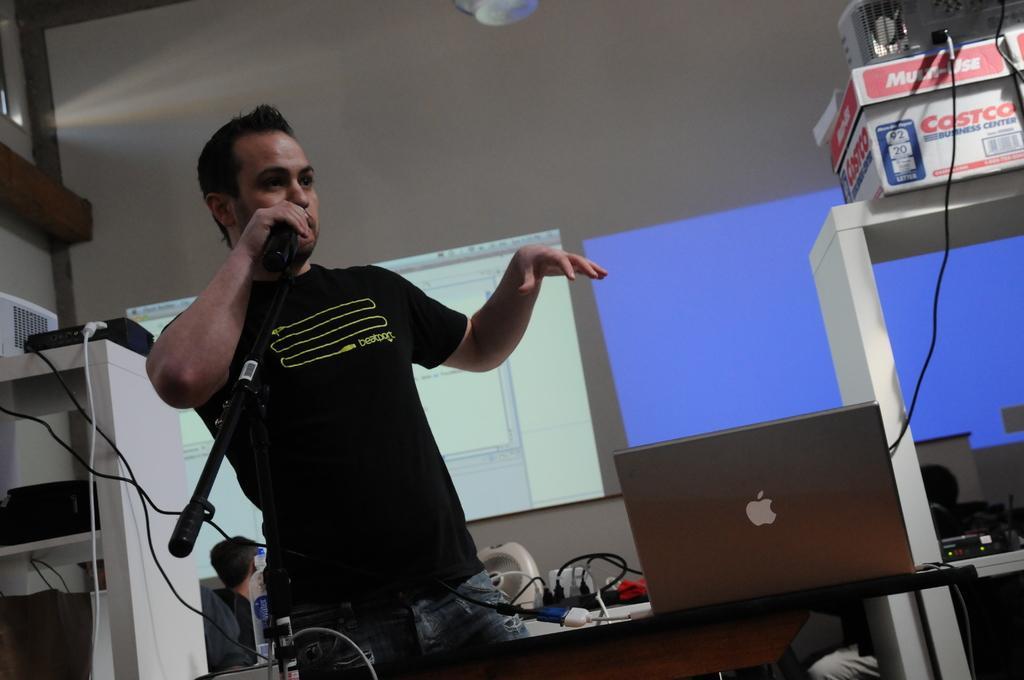How would you summarize this image in a sentence or two? In the foreground of the picture we can see cables, person, mic, table and some electronic gadgets. In the background we can see wall, person, projector screen and other objects. 